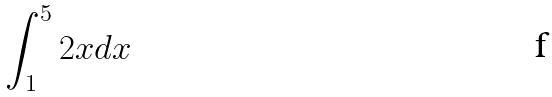Convert formula to latex. <formula><loc_0><loc_0><loc_500><loc_500>\int _ { 1 } ^ { 5 } 2 x d x</formula> 